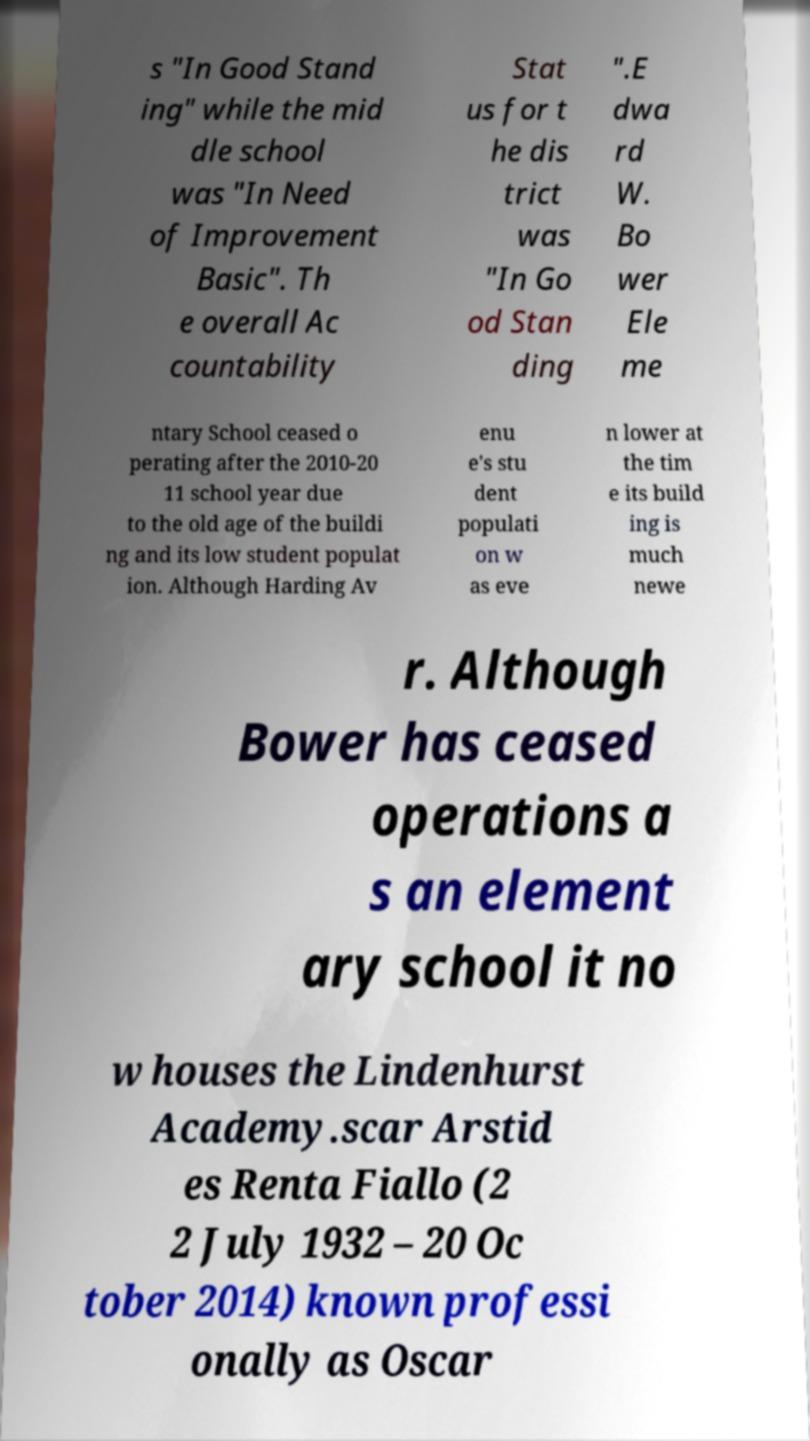For documentation purposes, I need the text within this image transcribed. Could you provide that? s "In Good Stand ing" while the mid dle school was "In Need of Improvement Basic". Th e overall Ac countability Stat us for t he dis trict was "In Go od Stan ding ".E dwa rd W. Bo wer Ele me ntary School ceased o perating after the 2010-20 11 school year due to the old age of the buildi ng and its low student populat ion. Although Harding Av enu e's stu dent populati on w as eve n lower at the tim e its build ing is much newe r. Although Bower has ceased operations a s an element ary school it no w houses the Lindenhurst Academy.scar Arstid es Renta Fiallo (2 2 July 1932 – 20 Oc tober 2014) known professi onally as Oscar 